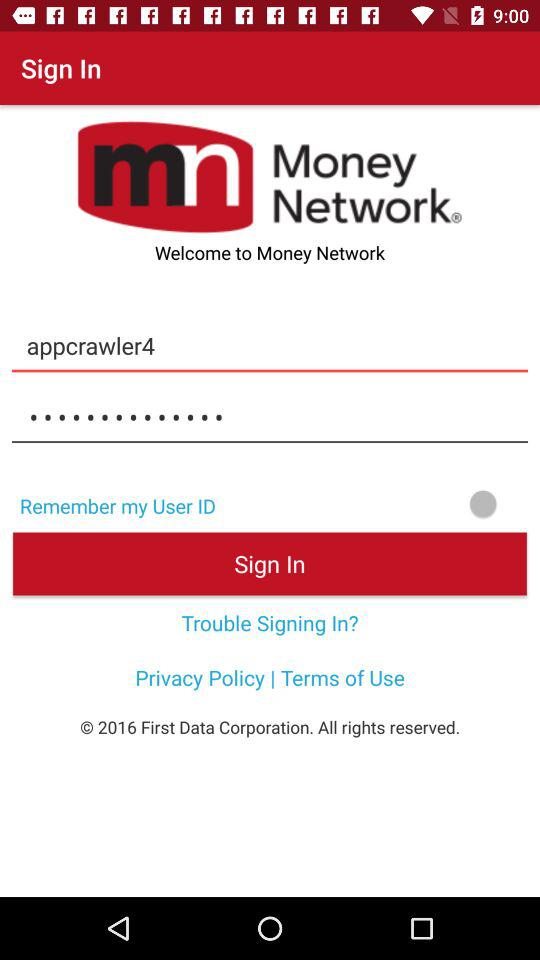What is the name of the application? The name of the application is "Money Network". 